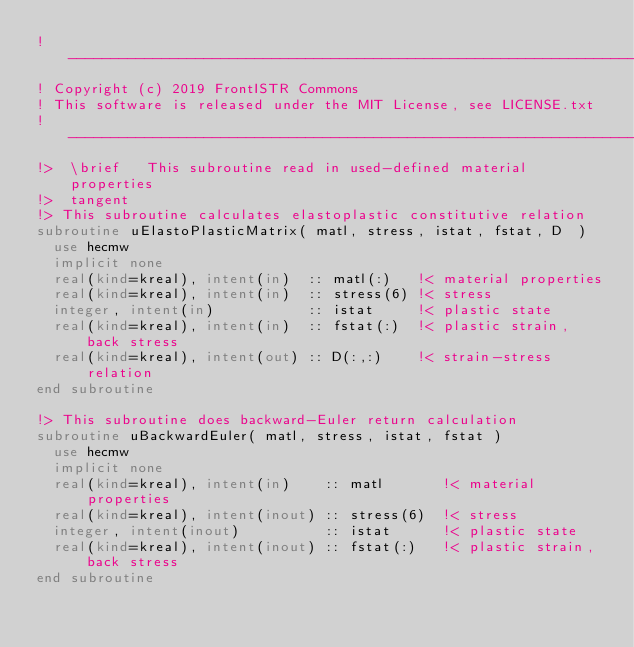Convert code to text. <code><loc_0><loc_0><loc_500><loc_500><_FORTRAN_>!-------------------------------------------------------------------------------
! Copyright (c) 2019 FrontISTR Commons
! This software is released under the MIT License, see LICENSE.txt
!-------------------------------------------------------------------------------
!>  \brief   This subroutine read in used-defined material properties
!>  tangent
!> This subroutine calculates elastoplastic constitutive relation
subroutine uElastoPlasticMatrix( matl, stress, istat, fstat, D  )
  use hecmw
  implicit none
  real(kind=kreal), intent(in)  :: matl(:)   !< material properties
  real(kind=kreal), intent(in)  :: stress(6) !< stress
  integer, intent(in)           :: istat     !< plastic state
  real(kind=kreal), intent(in)  :: fstat(:)  !< plastic strain, back stress
  real(kind=kreal), intent(out) :: D(:,:)    !< strain-stress relation
end subroutine

!> This subroutine does backward-Euler return calculation
subroutine uBackwardEuler( matl, stress, istat, fstat )
  use hecmw
  implicit none
  real(kind=kreal), intent(in)    :: matl       !< material properties
  real(kind=kreal), intent(inout) :: stress(6)  !< stress
  integer, intent(inout)          :: istat      !< plastic state
  real(kind=kreal), intent(inout) :: fstat(:)   !< plastic strain, back stress
end subroutine
</code> 